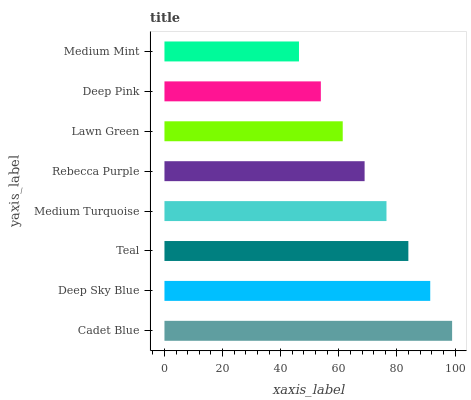Is Medium Mint the minimum?
Answer yes or no. Yes. Is Cadet Blue the maximum?
Answer yes or no. Yes. Is Deep Sky Blue the minimum?
Answer yes or no. No. Is Deep Sky Blue the maximum?
Answer yes or no. No. Is Cadet Blue greater than Deep Sky Blue?
Answer yes or no. Yes. Is Deep Sky Blue less than Cadet Blue?
Answer yes or no. Yes. Is Deep Sky Blue greater than Cadet Blue?
Answer yes or no. No. Is Cadet Blue less than Deep Sky Blue?
Answer yes or no. No. Is Medium Turquoise the high median?
Answer yes or no. Yes. Is Rebecca Purple the low median?
Answer yes or no. Yes. Is Medium Mint the high median?
Answer yes or no. No. Is Deep Sky Blue the low median?
Answer yes or no. No. 